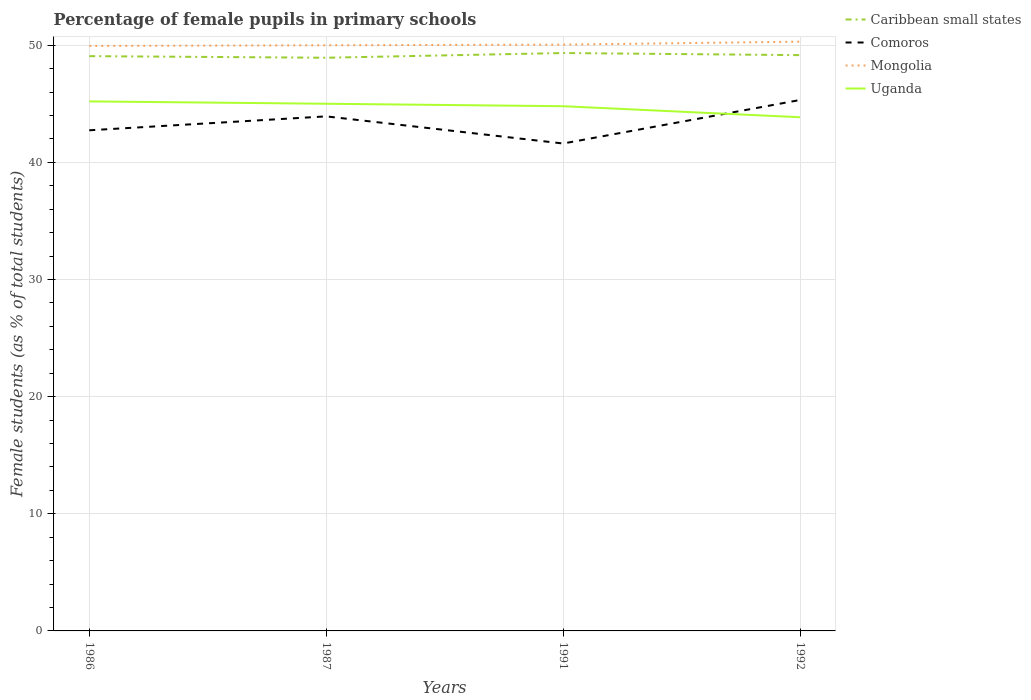How many different coloured lines are there?
Make the answer very short. 4. Does the line corresponding to Uganda intersect with the line corresponding to Mongolia?
Your response must be concise. No. Is the number of lines equal to the number of legend labels?
Provide a succinct answer. Yes. Across all years, what is the maximum percentage of female pupils in primary schools in Comoros?
Keep it short and to the point. 41.61. What is the total percentage of female pupils in primary schools in Caribbean small states in the graph?
Offer a terse response. -0.09. What is the difference between the highest and the second highest percentage of female pupils in primary schools in Uganda?
Your answer should be compact. 1.35. How many years are there in the graph?
Keep it short and to the point. 4. Are the values on the major ticks of Y-axis written in scientific E-notation?
Ensure brevity in your answer.  No. Does the graph contain grids?
Make the answer very short. Yes. Where does the legend appear in the graph?
Give a very brief answer. Top right. How many legend labels are there?
Make the answer very short. 4. What is the title of the graph?
Provide a short and direct response. Percentage of female pupils in primary schools. Does "Cameroon" appear as one of the legend labels in the graph?
Give a very brief answer. No. What is the label or title of the X-axis?
Your response must be concise. Years. What is the label or title of the Y-axis?
Provide a short and direct response. Female students (as % of total students). What is the Female students (as % of total students) of Caribbean small states in 1986?
Keep it short and to the point. 49.06. What is the Female students (as % of total students) in Comoros in 1986?
Your answer should be compact. 42.73. What is the Female students (as % of total students) of Mongolia in 1986?
Your answer should be compact. 49.94. What is the Female students (as % of total students) of Uganda in 1986?
Your answer should be compact. 45.2. What is the Female students (as % of total students) of Caribbean small states in 1987?
Ensure brevity in your answer.  48.93. What is the Female students (as % of total students) in Comoros in 1987?
Give a very brief answer. 43.92. What is the Female students (as % of total students) in Mongolia in 1987?
Give a very brief answer. 49.99. What is the Female students (as % of total students) in Uganda in 1987?
Your response must be concise. 45. What is the Female students (as % of total students) of Caribbean small states in 1991?
Keep it short and to the point. 49.33. What is the Female students (as % of total students) in Comoros in 1991?
Keep it short and to the point. 41.61. What is the Female students (as % of total students) of Mongolia in 1991?
Ensure brevity in your answer.  50.05. What is the Female students (as % of total students) in Uganda in 1991?
Ensure brevity in your answer.  44.79. What is the Female students (as % of total students) in Caribbean small states in 1992?
Offer a terse response. 49.15. What is the Female students (as % of total students) of Comoros in 1992?
Give a very brief answer. 45.32. What is the Female students (as % of total students) in Mongolia in 1992?
Offer a very short reply. 50.3. What is the Female students (as % of total students) in Uganda in 1992?
Provide a succinct answer. 43.85. Across all years, what is the maximum Female students (as % of total students) in Caribbean small states?
Your response must be concise. 49.33. Across all years, what is the maximum Female students (as % of total students) of Comoros?
Ensure brevity in your answer.  45.32. Across all years, what is the maximum Female students (as % of total students) in Mongolia?
Provide a short and direct response. 50.3. Across all years, what is the maximum Female students (as % of total students) in Uganda?
Ensure brevity in your answer.  45.2. Across all years, what is the minimum Female students (as % of total students) of Caribbean small states?
Give a very brief answer. 48.93. Across all years, what is the minimum Female students (as % of total students) in Comoros?
Provide a succinct answer. 41.61. Across all years, what is the minimum Female students (as % of total students) of Mongolia?
Offer a terse response. 49.94. Across all years, what is the minimum Female students (as % of total students) of Uganda?
Your response must be concise. 43.85. What is the total Female students (as % of total students) of Caribbean small states in the graph?
Ensure brevity in your answer.  196.47. What is the total Female students (as % of total students) of Comoros in the graph?
Offer a terse response. 173.59. What is the total Female students (as % of total students) of Mongolia in the graph?
Offer a terse response. 200.28. What is the total Female students (as % of total students) of Uganda in the graph?
Give a very brief answer. 178.84. What is the difference between the Female students (as % of total students) of Caribbean small states in 1986 and that in 1987?
Keep it short and to the point. 0.14. What is the difference between the Female students (as % of total students) in Comoros in 1986 and that in 1987?
Your answer should be very brief. -1.19. What is the difference between the Female students (as % of total students) of Mongolia in 1986 and that in 1987?
Offer a very short reply. -0.06. What is the difference between the Female students (as % of total students) in Uganda in 1986 and that in 1987?
Make the answer very short. 0.2. What is the difference between the Female students (as % of total students) of Caribbean small states in 1986 and that in 1991?
Keep it short and to the point. -0.27. What is the difference between the Female students (as % of total students) in Comoros in 1986 and that in 1991?
Offer a terse response. 1.13. What is the difference between the Female students (as % of total students) in Mongolia in 1986 and that in 1991?
Make the answer very short. -0.11. What is the difference between the Female students (as % of total students) of Uganda in 1986 and that in 1991?
Provide a short and direct response. 0.41. What is the difference between the Female students (as % of total students) in Caribbean small states in 1986 and that in 1992?
Offer a very short reply. -0.09. What is the difference between the Female students (as % of total students) of Comoros in 1986 and that in 1992?
Your answer should be compact. -2.59. What is the difference between the Female students (as % of total students) in Mongolia in 1986 and that in 1992?
Ensure brevity in your answer.  -0.36. What is the difference between the Female students (as % of total students) of Uganda in 1986 and that in 1992?
Your answer should be compact. 1.35. What is the difference between the Female students (as % of total students) of Caribbean small states in 1987 and that in 1991?
Give a very brief answer. -0.4. What is the difference between the Female students (as % of total students) in Comoros in 1987 and that in 1991?
Give a very brief answer. 2.32. What is the difference between the Female students (as % of total students) of Mongolia in 1987 and that in 1991?
Provide a short and direct response. -0.05. What is the difference between the Female students (as % of total students) in Uganda in 1987 and that in 1991?
Your answer should be very brief. 0.21. What is the difference between the Female students (as % of total students) in Caribbean small states in 1987 and that in 1992?
Your answer should be very brief. -0.22. What is the difference between the Female students (as % of total students) of Comoros in 1987 and that in 1992?
Your answer should be compact. -1.4. What is the difference between the Female students (as % of total students) of Mongolia in 1987 and that in 1992?
Offer a terse response. -0.31. What is the difference between the Female students (as % of total students) in Uganda in 1987 and that in 1992?
Offer a terse response. 1.15. What is the difference between the Female students (as % of total students) of Caribbean small states in 1991 and that in 1992?
Your answer should be very brief. 0.18. What is the difference between the Female students (as % of total students) of Comoros in 1991 and that in 1992?
Make the answer very short. -3.71. What is the difference between the Female students (as % of total students) of Mongolia in 1991 and that in 1992?
Ensure brevity in your answer.  -0.25. What is the difference between the Female students (as % of total students) of Uganda in 1991 and that in 1992?
Keep it short and to the point. 0.94. What is the difference between the Female students (as % of total students) of Caribbean small states in 1986 and the Female students (as % of total students) of Comoros in 1987?
Offer a terse response. 5.14. What is the difference between the Female students (as % of total students) in Caribbean small states in 1986 and the Female students (as % of total students) in Mongolia in 1987?
Provide a succinct answer. -0.93. What is the difference between the Female students (as % of total students) in Caribbean small states in 1986 and the Female students (as % of total students) in Uganda in 1987?
Offer a terse response. 4.06. What is the difference between the Female students (as % of total students) of Comoros in 1986 and the Female students (as % of total students) of Mongolia in 1987?
Your answer should be compact. -7.26. What is the difference between the Female students (as % of total students) of Comoros in 1986 and the Female students (as % of total students) of Uganda in 1987?
Offer a very short reply. -2.27. What is the difference between the Female students (as % of total students) in Mongolia in 1986 and the Female students (as % of total students) in Uganda in 1987?
Give a very brief answer. 4.94. What is the difference between the Female students (as % of total students) of Caribbean small states in 1986 and the Female students (as % of total students) of Comoros in 1991?
Keep it short and to the point. 7.46. What is the difference between the Female students (as % of total students) in Caribbean small states in 1986 and the Female students (as % of total students) in Mongolia in 1991?
Give a very brief answer. -0.98. What is the difference between the Female students (as % of total students) in Caribbean small states in 1986 and the Female students (as % of total students) in Uganda in 1991?
Keep it short and to the point. 4.27. What is the difference between the Female students (as % of total students) in Comoros in 1986 and the Female students (as % of total students) in Mongolia in 1991?
Keep it short and to the point. -7.31. What is the difference between the Female students (as % of total students) in Comoros in 1986 and the Female students (as % of total students) in Uganda in 1991?
Your answer should be very brief. -2.06. What is the difference between the Female students (as % of total students) in Mongolia in 1986 and the Female students (as % of total students) in Uganda in 1991?
Make the answer very short. 5.15. What is the difference between the Female students (as % of total students) of Caribbean small states in 1986 and the Female students (as % of total students) of Comoros in 1992?
Offer a very short reply. 3.74. What is the difference between the Female students (as % of total students) in Caribbean small states in 1986 and the Female students (as % of total students) in Mongolia in 1992?
Your answer should be very brief. -1.24. What is the difference between the Female students (as % of total students) in Caribbean small states in 1986 and the Female students (as % of total students) in Uganda in 1992?
Make the answer very short. 5.21. What is the difference between the Female students (as % of total students) of Comoros in 1986 and the Female students (as % of total students) of Mongolia in 1992?
Ensure brevity in your answer.  -7.57. What is the difference between the Female students (as % of total students) of Comoros in 1986 and the Female students (as % of total students) of Uganda in 1992?
Offer a very short reply. -1.12. What is the difference between the Female students (as % of total students) in Mongolia in 1986 and the Female students (as % of total students) in Uganda in 1992?
Provide a short and direct response. 6.09. What is the difference between the Female students (as % of total students) of Caribbean small states in 1987 and the Female students (as % of total students) of Comoros in 1991?
Offer a very short reply. 7.32. What is the difference between the Female students (as % of total students) of Caribbean small states in 1987 and the Female students (as % of total students) of Mongolia in 1991?
Keep it short and to the point. -1.12. What is the difference between the Female students (as % of total students) in Caribbean small states in 1987 and the Female students (as % of total students) in Uganda in 1991?
Your answer should be compact. 4.14. What is the difference between the Female students (as % of total students) of Comoros in 1987 and the Female students (as % of total students) of Mongolia in 1991?
Your answer should be compact. -6.12. What is the difference between the Female students (as % of total students) of Comoros in 1987 and the Female students (as % of total students) of Uganda in 1991?
Your response must be concise. -0.87. What is the difference between the Female students (as % of total students) of Mongolia in 1987 and the Female students (as % of total students) of Uganda in 1991?
Make the answer very short. 5.2. What is the difference between the Female students (as % of total students) in Caribbean small states in 1987 and the Female students (as % of total students) in Comoros in 1992?
Provide a short and direct response. 3.61. What is the difference between the Female students (as % of total students) of Caribbean small states in 1987 and the Female students (as % of total students) of Mongolia in 1992?
Give a very brief answer. -1.37. What is the difference between the Female students (as % of total students) of Caribbean small states in 1987 and the Female students (as % of total students) of Uganda in 1992?
Keep it short and to the point. 5.08. What is the difference between the Female students (as % of total students) of Comoros in 1987 and the Female students (as % of total students) of Mongolia in 1992?
Ensure brevity in your answer.  -6.38. What is the difference between the Female students (as % of total students) of Comoros in 1987 and the Female students (as % of total students) of Uganda in 1992?
Ensure brevity in your answer.  0.07. What is the difference between the Female students (as % of total students) of Mongolia in 1987 and the Female students (as % of total students) of Uganda in 1992?
Offer a very short reply. 6.14. What is the difference between the Female students (as % of total students) in Caribbean small states in 1991 and the Female students (as % of total students) in Comoros in 1992?
Keep it short and to the point. 4.01. What is the difference between the Female students (as % of total students) of Caribbean small states in 1991 and the Female students (as % of total students) of Mongolia in 1992?
Offer a very short reply. -0.97. What is the difference between the Female students (as % of total students) of Caribbean small states in 1991 and the Female students (as % of total students) of Uganda in 1992?
Offer a terse response. 5.48. What is the difference between the Female students (as % of total students) in Comoros in 1991 and the Female students (as % of total students) in Mongolia in 1992?
Make the answer very short. -8.69. What is the difference between the Female students (as % of total students) of Comoros in 1991 and the Female students (as % of total students) of Uganda in 1992?
Provide a short and direct response. -2.24. What is the difference between the Female students (as % of total students) in Mongolia in 1991 and the Female students (as % of total students) in Uganda in 1992?
Offer a very short reply. 6.2. What is the average Female students (as % of total students) of Caribbean small states per year?
Your answer should be compact. 49.12. What is the average Female students (as % of total students) in Comoros per year?
Provide a succinct answer. 43.4. What is the average Female students (as % of total students) of Mongolia per year?
Provide a short and direct response. 50.07. What is the average Female students (as % of total students) in Uganda per year?
Provide a succinct answer. 44.71. In the year 1986, what is the difference between the Female students (as % of total students) in Caribbean small states and Female students (as % of total students) in Comoros?
Keep it short and to the point. 6.33. In the year 1986, what is the difference between the Female students (as % of total students) in Caribbean small states and Female students (as % of total students) in Mongolia?
Ensure brevity in your answer.  -0.87. In the year 1986, what is the difference between the Female students (as % of total students) in Caribbean small states and Female students (as % of total students) in Uganda?
Keep it short and to the point. 3.86. In the year 1986, what is the difference between the Female students (as % of total students) of Comoros and Female students (as % of total students) of Mongolia?
Your answer should be compact. -7.2. In the year 1986, what is the difference between the Female students (as % of total students) in Comoros and Female students (as % of total students) in Uganda?
Make the answer very short. -2.47. In the year 1986, what is the difference between the Female students (as % of total students) of Mongolia and Female students (as % of total students) of Uganda?
Provide a succinct answer. 4.73. In the year 1987, what is the difference between the Female students (as % of total students) of Caribbean small states and Female students (as % of total students) of Comoros?
Your answer should be very brief. 5. In the year 1987, what is the difference between the Female students (as % of total students) of Caribbean small states and Female students (as % of total students) of Mongolia?
Give a very brief answer. -1.06. In the year 1987, what is the difference between the Female students (as % of total students) in Caribbean small states and Female students (as % of total students) in Uganda?
Offer a terse response. 3.93. In the year 1987, what is the difference between the Female students (as % of total students) of Comoros and Female students (as % of total students) of Mongolia?
Provide a succinct answer. -6.07. In the year 1987, what is the difference between the Female students (as % of total students) of Comoros and Female students (as % of total students) of Uganda?
Provide a short and direct response. -1.08. In the year 1987, what is the difference between the Female students (as % of total students) of Mongolia and Female students (as % of total students) of Uganda?
Make the answer very short. 4.99. In the year 1991, what is the difference between the Female students (as % of total students) in Caribbean small states and Female students (as % of total students) in Comoros?
Ensure brevity in your answer.  7.72. In the year 1991, what is the difference between the Female students (as % of total students) of Caribbean small states and Female students (as % of total students) of Mongolia?
Keep it short and to the point. -0.72. In the year 1991, what is the difference between the Female students (as % of total students) of Caribbean small states and Female students (as % of total students) of Uganda?
Make the answer very short. 4.54. In the year 1991, what is the difference between the Female students (as % of total students) of Comoros and Female students (as % of total students) of Mongolia?
Offer a terse response. -8.44. In the year 1991, what is the difference between the Female students (as % of total students) in Comoros and Female students (as % of total students) in Uganda?
Provide a succinct answer. -3.18. In the year 1991, what is the difference between the Female students (as % of total students) of Mongolia and Female students (as % of total students) of Uganda?
Your response must be concise. 5.26. In the year 1992, what is the difference between the Female students (as % of total students) of Caribbean small states and Female students (as % of total students) of Comoros?
Offer a terse response. 3.83. In the year 1992, what is the difference between the Female students (as % of total students) of Caribbean small states and Female students (as % of total students) of Mongolia?
Your response must be concise. -1.15. In the year 1992, what is the difference between the Female students (as % of total students) of Caribbean small states and Female students (as % of total students) of Uganda?
Offer a very short reply. 5.3. In the year 1992, what is the difference between the Female students (as % of total students) in Comoros and Female students (as % of total students) in Mongolia?
Your answer should be very brief. -4.98. In the year 1992, what is the difference between the Female students (as % of total students) of Comoros and Female students (as % of total students) of Uganda?
Give a very brief answer. 1.47. In the year 1992, what is the difference between the Female students (as % of total students) in Mongolia and Female students (as % of total students) in Uganda?
Ensure brevity in your answer.  6.45. What is the ratio of the Female students (as % of total students) in Caribbean small states in 1986 to that in 1987?
Your response must be concise. 1. What is the ratio of the Female students (as % of total students) in Comoros in 1986 to that in 1987?
Your answer should be very brief. 0.97. What is the ratio of the Female students (as % of total students) of Caribbean small states in 1986 to that in 1991?
Give a very brief answer. 0.99. What is the ratio of the Female students (as % of total students) in Comoros in 1986 to that in 1991?
Your response must be concise. 1.03. What is the ratio of the Female students (as % of total students) in Mongolia in 1986 to that in 1991?
Ensure brevity in your answer.  1. What is the ratio of the Female students (as % of total students) in Uganda in 1986 to that in 1991?
Give a very brief answer. 1.01. What is the ratio of the Female students (as % of total students) in Comoros in 1986 to that in 1992?
Ensure brevity in your answer.  0.94. What is the ratio of the Female students (as % of total students) in Mongolia in 1986 to that in 1992?
Make the answer very short. 0.99. What is the ratio of the Female students (as % of total students) in Uganda in 1986 to that in 1992?
Give a very brief answer. 1.03. What is the ratio of the Female students (as % of total students) of Caribbean small states in 1987 to that in 1991?
Your answer should be very brief. 0.99. What is the ratio of the Female students (as % of total students) of Comoros in 1987 to that in 1991?
Give a very brief answer. 1.06. What is the ratio of the Female students (as % of total students) of Caribbean small states in 1987 to that in 1992?
Offer a very short reply. 1. What is the ratio of the Female students (as % of total students) in Comoros in 1987 to that in 1992?
Provide a short and direct response. 0.97. What is the ratio of the Female students (as % of total students) of Uganda in 1987 to that in 1992?
Your answer should be compact. 1.03. What is the ratio of the Female students (as % of total students) of Caribbean small states in 1991 to that in 1992?
Give a very brief answer. 1. What is the ratio of the Female students (as % of total students) of Comoros in 1991 to that in 1992?
Make the answer very short. 0.92. What is the ratio of the Female students (as % of total students) in Mongolia in 1991 to that in 1992?
Ensure brevity in your answer.  0.99. What is the ratio of the Female students (as % of total students) in Uganda in 1991 to that in 1992?
Your answer should be very brief. 1.02. What is the difference between the highest and the second highest Female students (as % of total students) of Caribbean small states?
Offer a terse response. 0.18. What is the difference between the highest and the second highest Female students (as % of total students) of Comoros?
Give a very brief answer. 1.4. What is the difference between the highest and the second highest Female students (as % of total students) in Mongolia?
Provide a short and direct response. 0.25. What is the difference between the highest and the second highest Female students (as % of total students) of Uganda?
Provide a short and direct response. 0.2. What is the difference between the highest and the lowest Female students (as % of total students) in Caribbean small states?
Your answer should be compact. 0.4. What is the difference between the highest and the lowest Female students (as % of total students) of Comoros?
Provide a short and direct response. 3.71. What is the difference between the highest and the lowest Female students (as % of total students) of Mongolia?
Provide a succinct answer. 0.36. What is the difference between the highest and the lowest Female students (as % of total students) in Uganda?
Your answer should be compact. 1.35. 